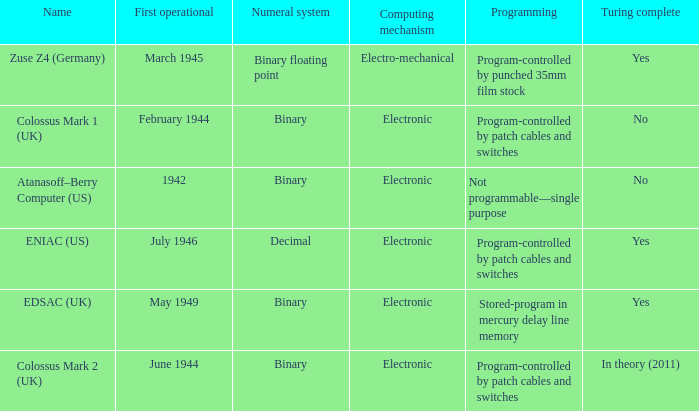In february 1944, what computing device was first put into operation? Electronic. 